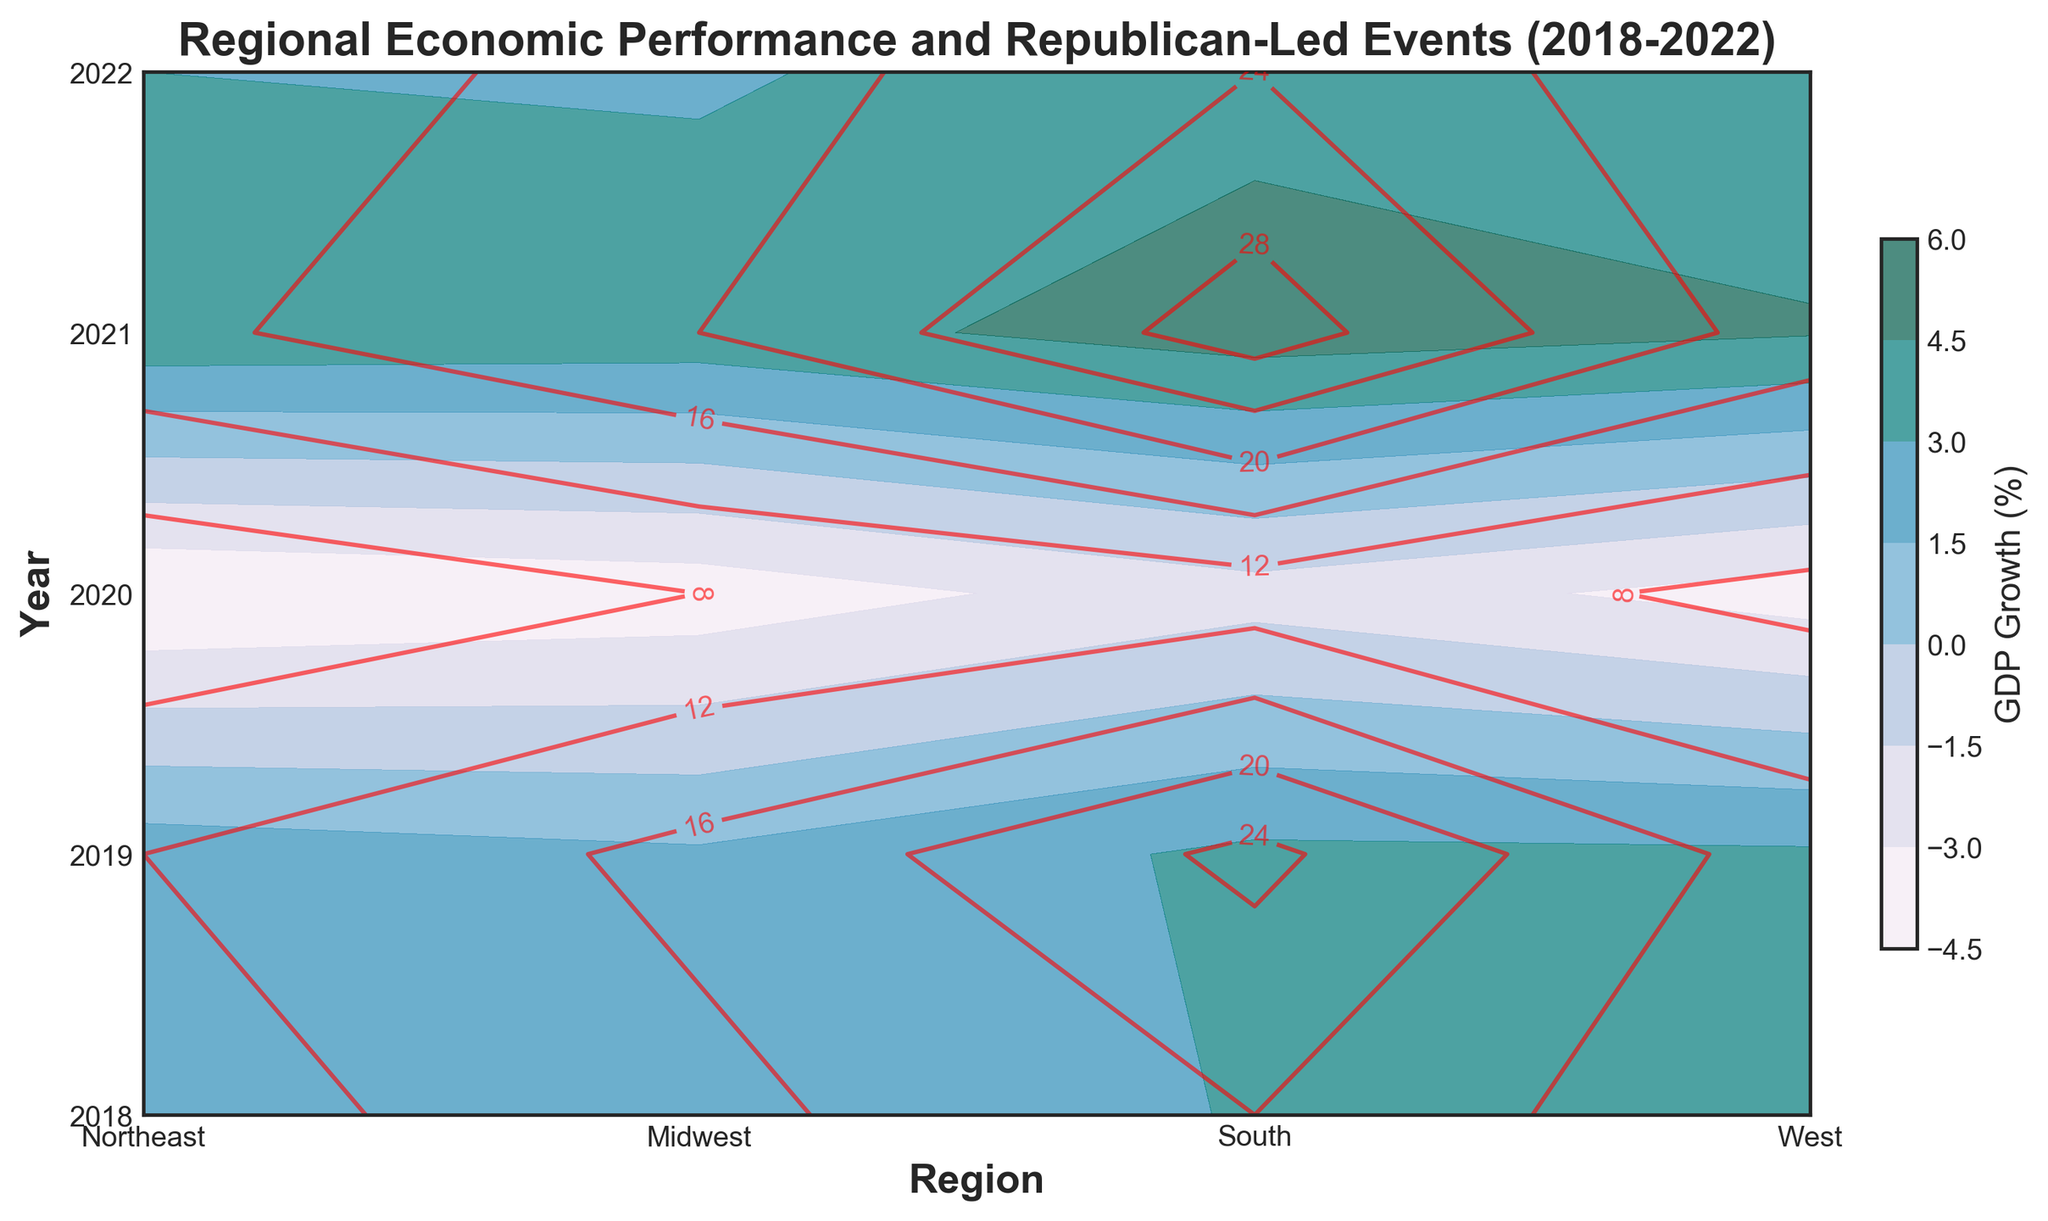What is the overall trend in GDP growth from 2018 to 2022 for all regions? By visually observing the contour shades over the years, we can see that the GDP growth generally increases from 2018 to 2019, decreases sharply in 2020 due to the negative values, and then increases again in 2021 and 2022.
Answer: Uniformly increasing until 2020, sharply decreasing in 2020, and then increasing again Which region had the highest GDP growth in 2021? By looking at the darkest blue to greenish-blue shades for 2021, the South region has the most intense color indicating the highest GDP growth.
Answer: South In which year did the Northeast region experience the lowest GDP growth? We examine the contour shades for the Northeast region across all years. The lowest shade (darkest blue) corresponds to the year 2020.
Answer: 2020 Compare the frequency of Republican-led events in 2018 and 2021 in the Midwest region. For the Midwest region, we check the contour lines labeled for Republican-led events for the years 2018 and 2021. In 2018 it reads around 15 events, while in 2021 it reads around 20 events.
Answer: Increased from 15 to 20 events What was the difference in GDP growth between the West and the South regions in 2020? Checking the contour shades for 2020, the West has a GDP growth indicated by around -3.7%, and the South has a growth indicated by around -2.1%. The difference is calculated as -2.1 - (-3.7) = 1.6%.
Answer: 1.6% Which region consistently hosted more Republican-led events from 2018 to 2022? By following the red contour lines across the years, the South region consistently has the most Republican-led events each year.
Answer: South Compare the GDP growth trends between the West and Northeast regions from 2018 to 2022. Observing the contour shades, both regions have similar trends, with GDP growth increasing until 2019, decreasing substantially in 2020, and recovering in 2021 and 2022. The West typically shows slightly higher growth than the Northeast.
Answer: Parallel trend, West generally higher How did the GDP growth in the Midwest region change from 2019 to 2020? Looking at the contour shade change, the Midwest went from a middle shade in 2019 to a darker blue shade in 2020, indicating a negative growth shift. From 1.7% growth in 2019 to -3.9% in 2020.
Answer: Decreased by 5.6% Which year had the highest frequency of Republican-led events for the South region? Checking the red contour labels for the South region, the highest number is seen in 2021 with 30 events.
Answer: 2021 Is there any year when all regions had negative GDP growth? Observing the contour shades for all regions in each year, the year 2020 shows all regions have dark blue shades indicating negative GDP growth.
Answer: 2020 